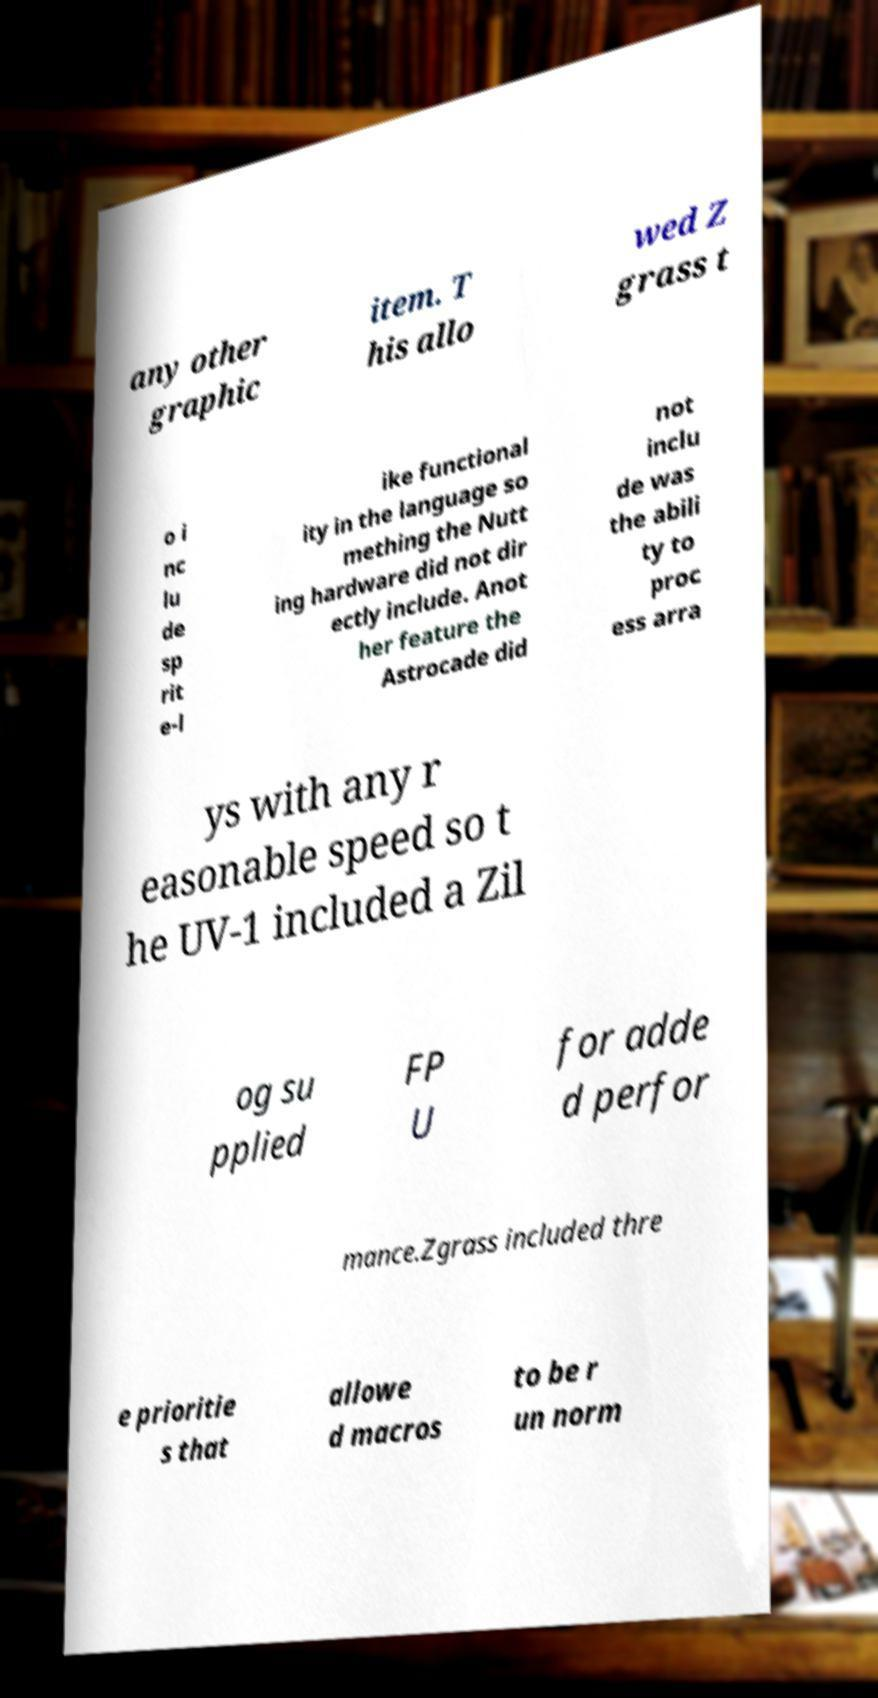For documentation purposes, I need the text within this image transcribed. Could you provide that? any other graphic item. T his allo wed Z grass t o i nc lu de sp rit e-l ike functional ity in the language so mething the Nutt ing hardware did not dir ectly include. Anot her feature the Astrocade did not inclu de was the abili ty to proc ess arra ys with any r easonable speed so t he UV-1 included a Zil og su pplied FP U for adde d perfor mance.Zgrass included thre e prioritie s that allowe d macros to be r un norm 